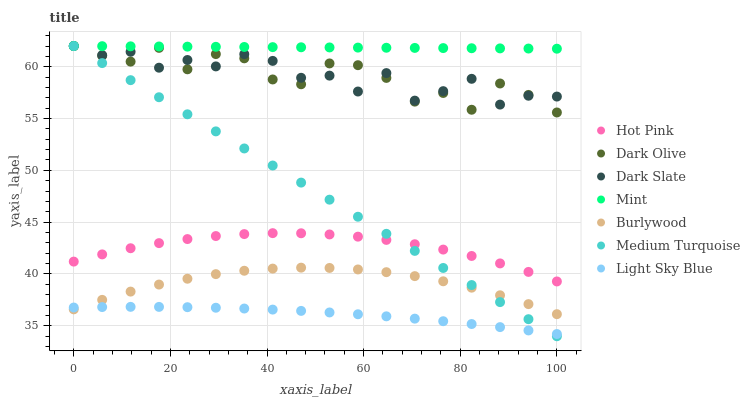Does Light Sky Blue have the minimum area under the curve?
Answer yes or no. Yes. Does Mint have the maximum area under the curve?
Answer yes or no. Yes. Does Burlywood have the minimum area under the curve?
Answer yes or no. No. Does Burlywood have the maximum area under the curve?
Answer yes or no. No. Is Medium Turquoise the smoothest?
Answer yes or no. Yes. Is Dark Olive the roughest?
Answer yes or no. Yes. Is Burlywood the smoothest?
Answer yes or no. No. Is Burlywood the roughest?
Answer yes or no. No. Does Medium Turquoise have the lowest value?
Answer yes or no. Yes. Does Burlywood have the lowest value?
Answer yes or no. No. Does Mint have the highest value?
Answer yes or no. Yes. Does Burlywood have the highest value?
Answer yes or no. No. Is Burlywood less than Hot Pink?
Answer yes or no. Yes. Is Dark Olive greater than Light Sky Blue?
Answer yes or no. Yes. Does Medium Turquoise intersect Hot Pink?
Answer yes or no. Yes. Is Medium Turquoise less than Hot Pink?
Answer yes or no. No. Is Medium Turquoise greater than Hot Pink?
Answer yes or no. No. Does Burlywood intersect Hot Pink?
Answer yes or no. No. 